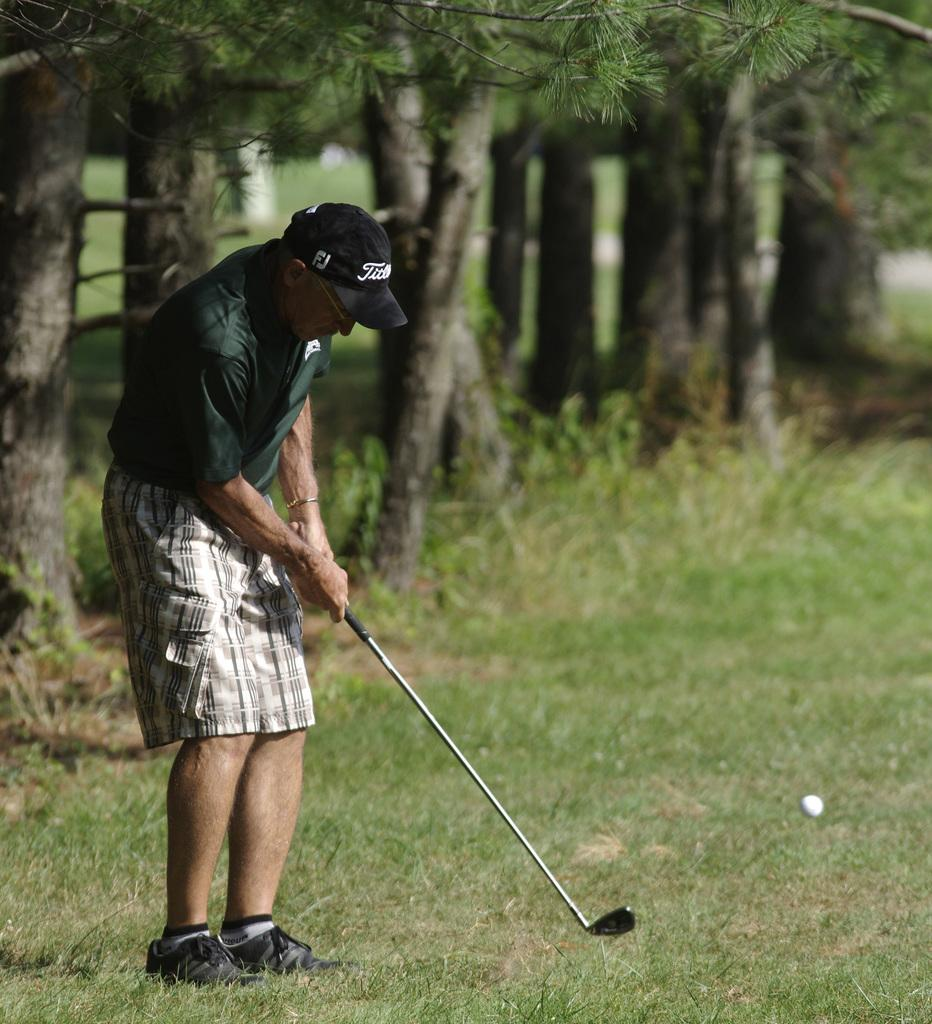What is the main subject in the foreground of the picture? There is a man in the foreground of the picture. What is the man holding in his hand? The man is holding a golf bat in his hand. What can be seen in the background of the picture? There is a ball in the air and grass visible in the background of the picture. What type of vegetation is present in the background? There are trees in the background of the picture. What time of day is it in the image, and how do you know? The time of day cannot be determined from the image, as there are no specific clues or indicators present. 